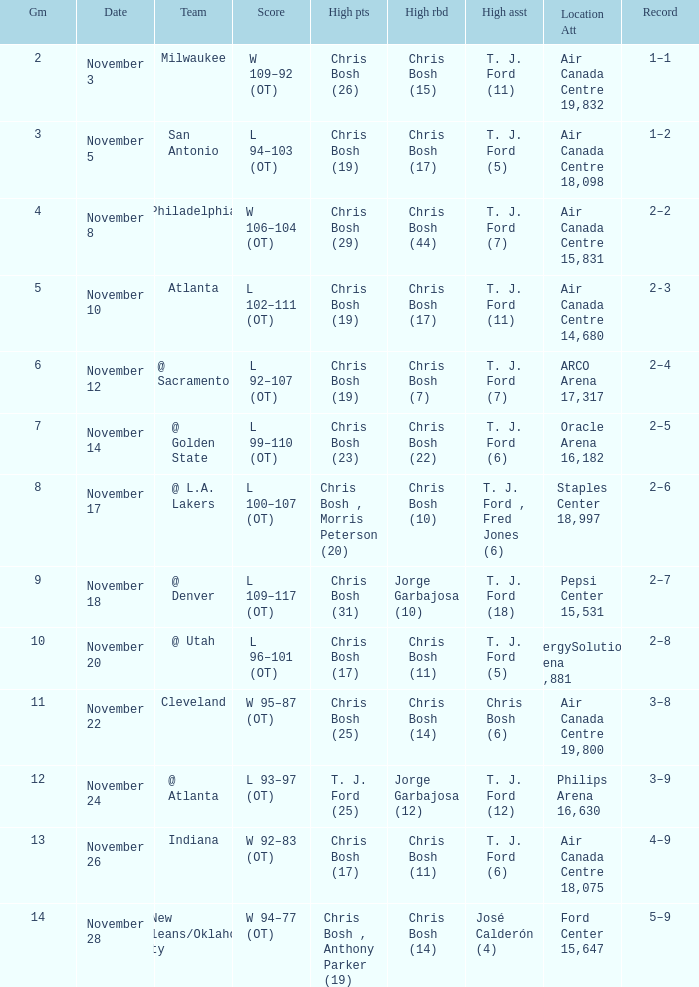Who had high assists when they played against San Antonio? T. J. Ford (5). 